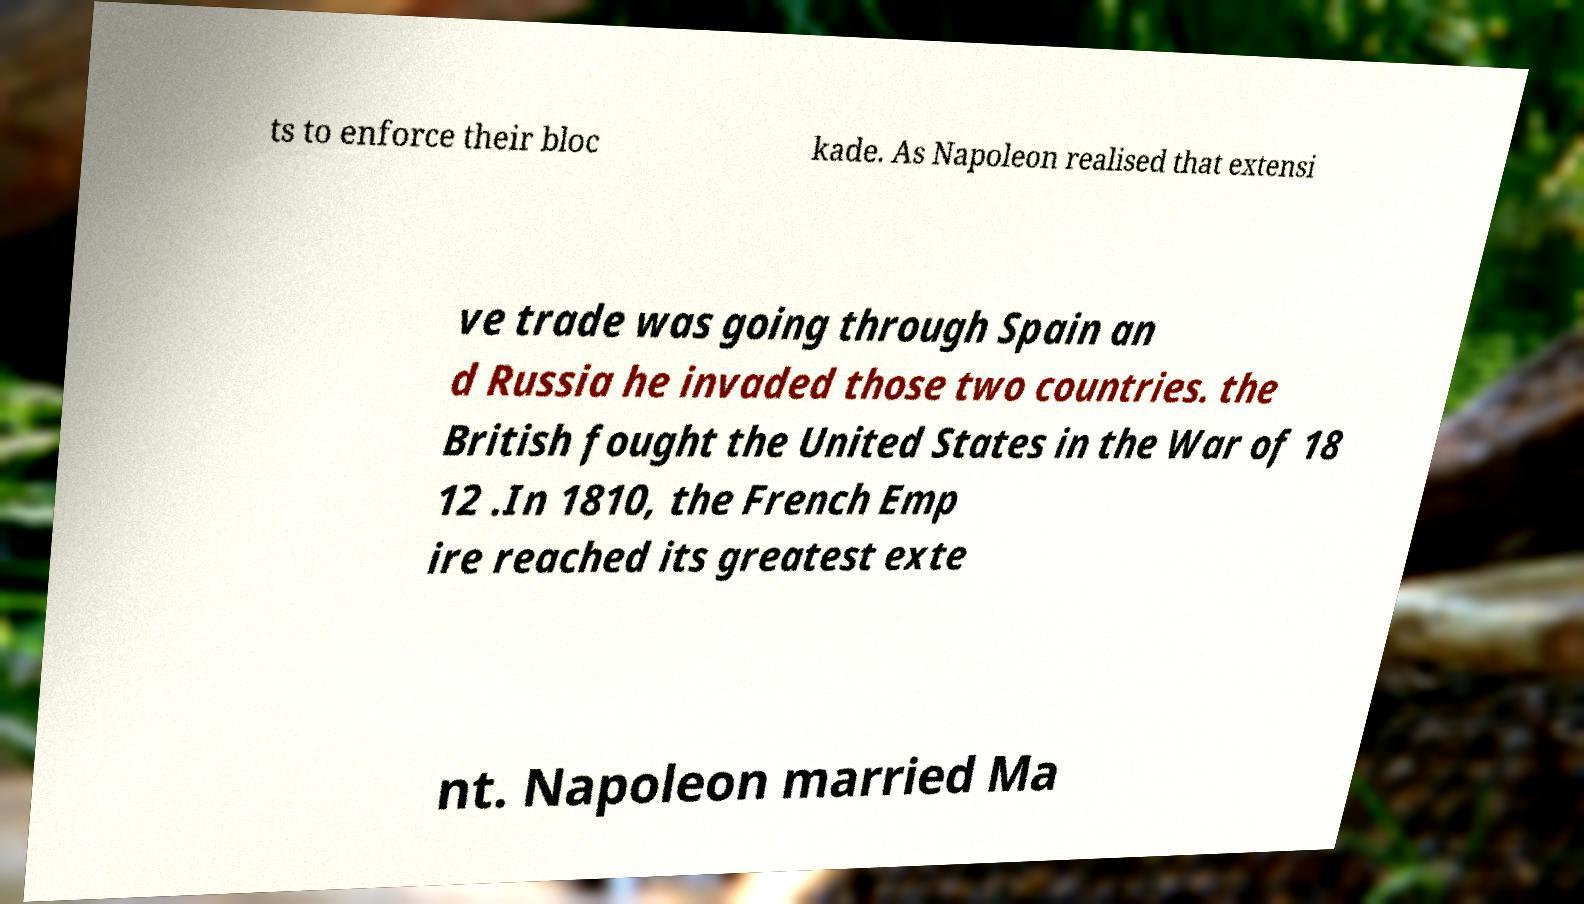Could you assist in decoding the text presented in this image and type it out clearly? ts to enforce their bloc kade. As Napoleon realised that extensi ve trade was going through Spain an d Russia he invaded those two countries. the British fought the United States in the War of 18 12 .In 1810, the French Emp ire reached its greatest exte nt. Napoleon married Ma 